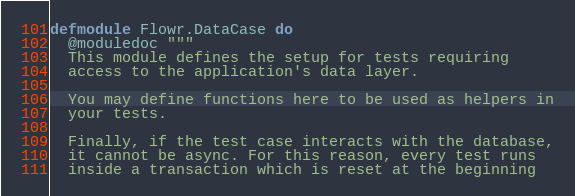<code> <loc_0><loc_0><loc_500><loc_500><_Elixir_>defmodule Flowr.DataCase do
  @moduledoc """
  This module defines the setup for tests requiring
  access to the application's data layer.

  You may define functions here to be used as helpers in
  your tests.

  Finally, if the test case interacts with the database,
  it cannot be async. For this reason, every test runs
  inside a transaction which is reset at the beginning</code> 